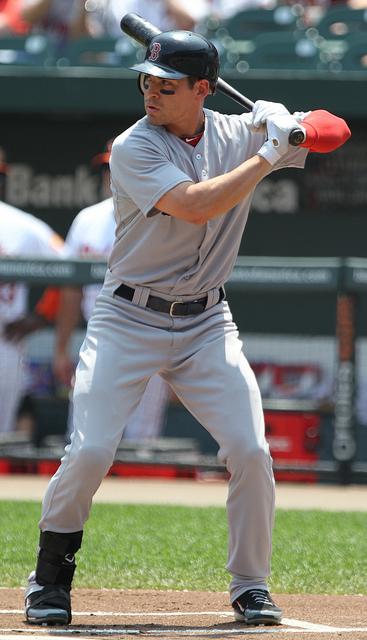What team does this person play for?
Answer briefly. Boston red sox. What letter is on his helmet?
Give a very brief answer. B. Is this a left handed or right handed batter?
Short answer required. Left. IS this man's face tense?
Be succinct. Yes. Is he wearing a helmet?
Write a very short answer. Yes. 